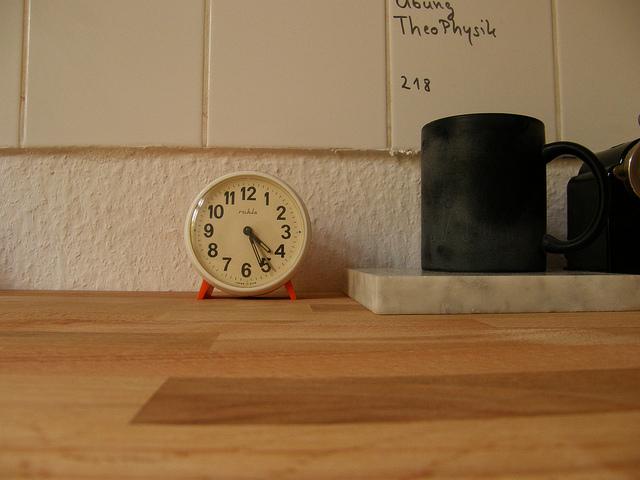What time is it on the alarm clock?
Give a very brief answer. 4:26. Is this a wall clock?
Concise answer only. No. What does the writing say on the wall?
Keep it brief. Abung theophysik 218. What is written on the tile?
Quick response, please. Theophysile 218. What are they doing to the alarm clock?
Concise answer only. Nothing. How many teapots are in the photo?
Give a very brief answer. 0. What time is it?
Answer briefly. 4:26. Are these advertisement items?
Be succinct. No. 